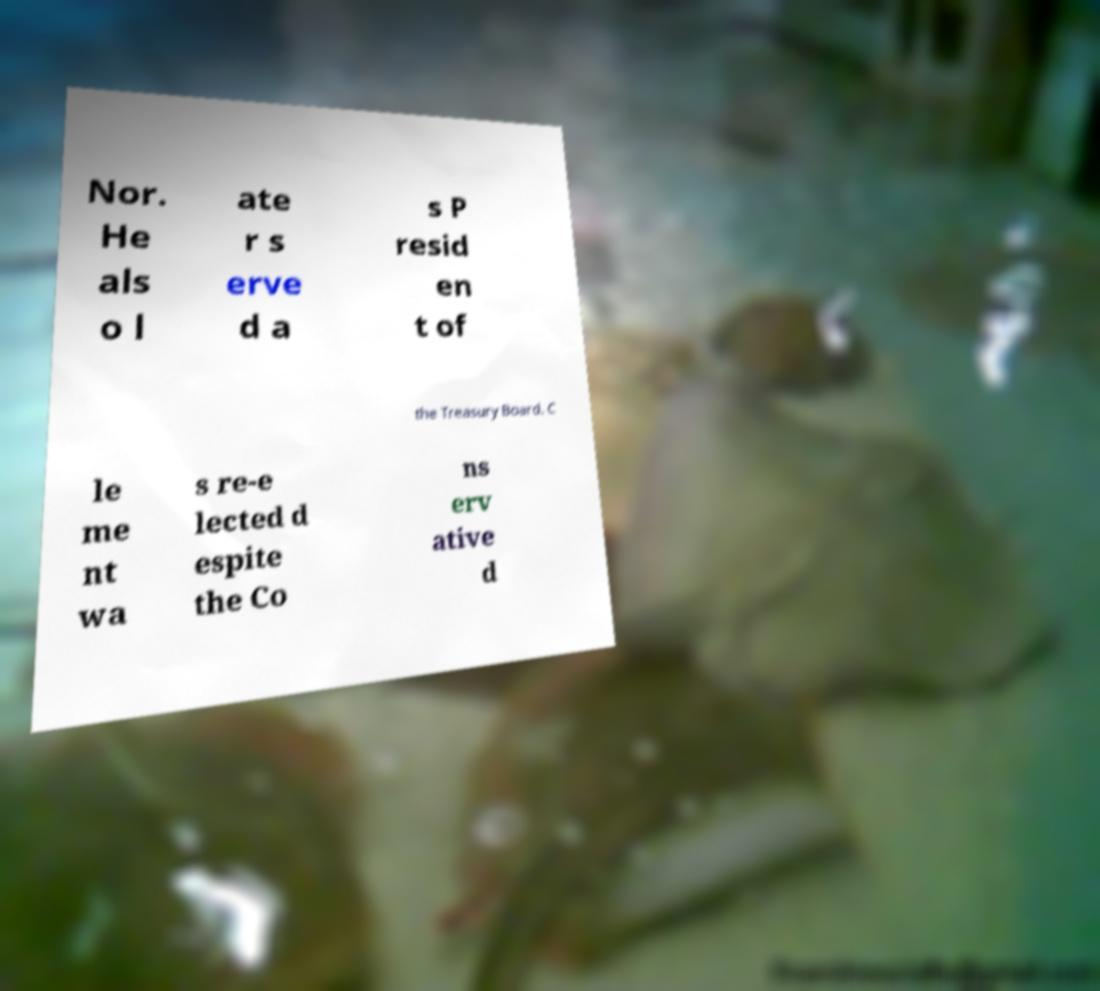There's text embedded in this image that I need extracted. Can you transcribe it verbatim? Nor. He als o l ate r s erve d a s P resid en t of the Treasury Board. C le me nt wa s re-e lected d espite the Co ns erv ative d 